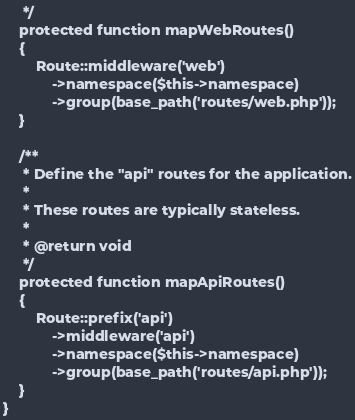<code> <loc_0><loc_0><loc_500><loc_500><_PHP_>     */
    protected function mapWebRoutes()
    {
        Route::middleware('web')
            ->namespace($this->namespace)
            ->group(base_path('routes/web.php'));
    }

    /**
     * Define the "api" routes for the application.
     *
     * These routes are typically stateless.
     *
     * @return void
     */
    protected function mapApiRoutes()
    {
        Route::prefix('api')
            ->middleware('api')
            ->namespace($this->namespace)
            ->group(base_path('routes/api.php'));
    }
}
</code> 